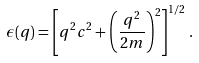<formula> <loc_0><loc_0><loc_500><loc_500>\epsilon ( q ) = \left [ q ^ { 2 } c ^ { 2 } + \left ( \frac { q ^ { 2 } } { 2 m } \right ) ^ { 2 } \right ] ^ { 1 / 2 } \, .</formula> 